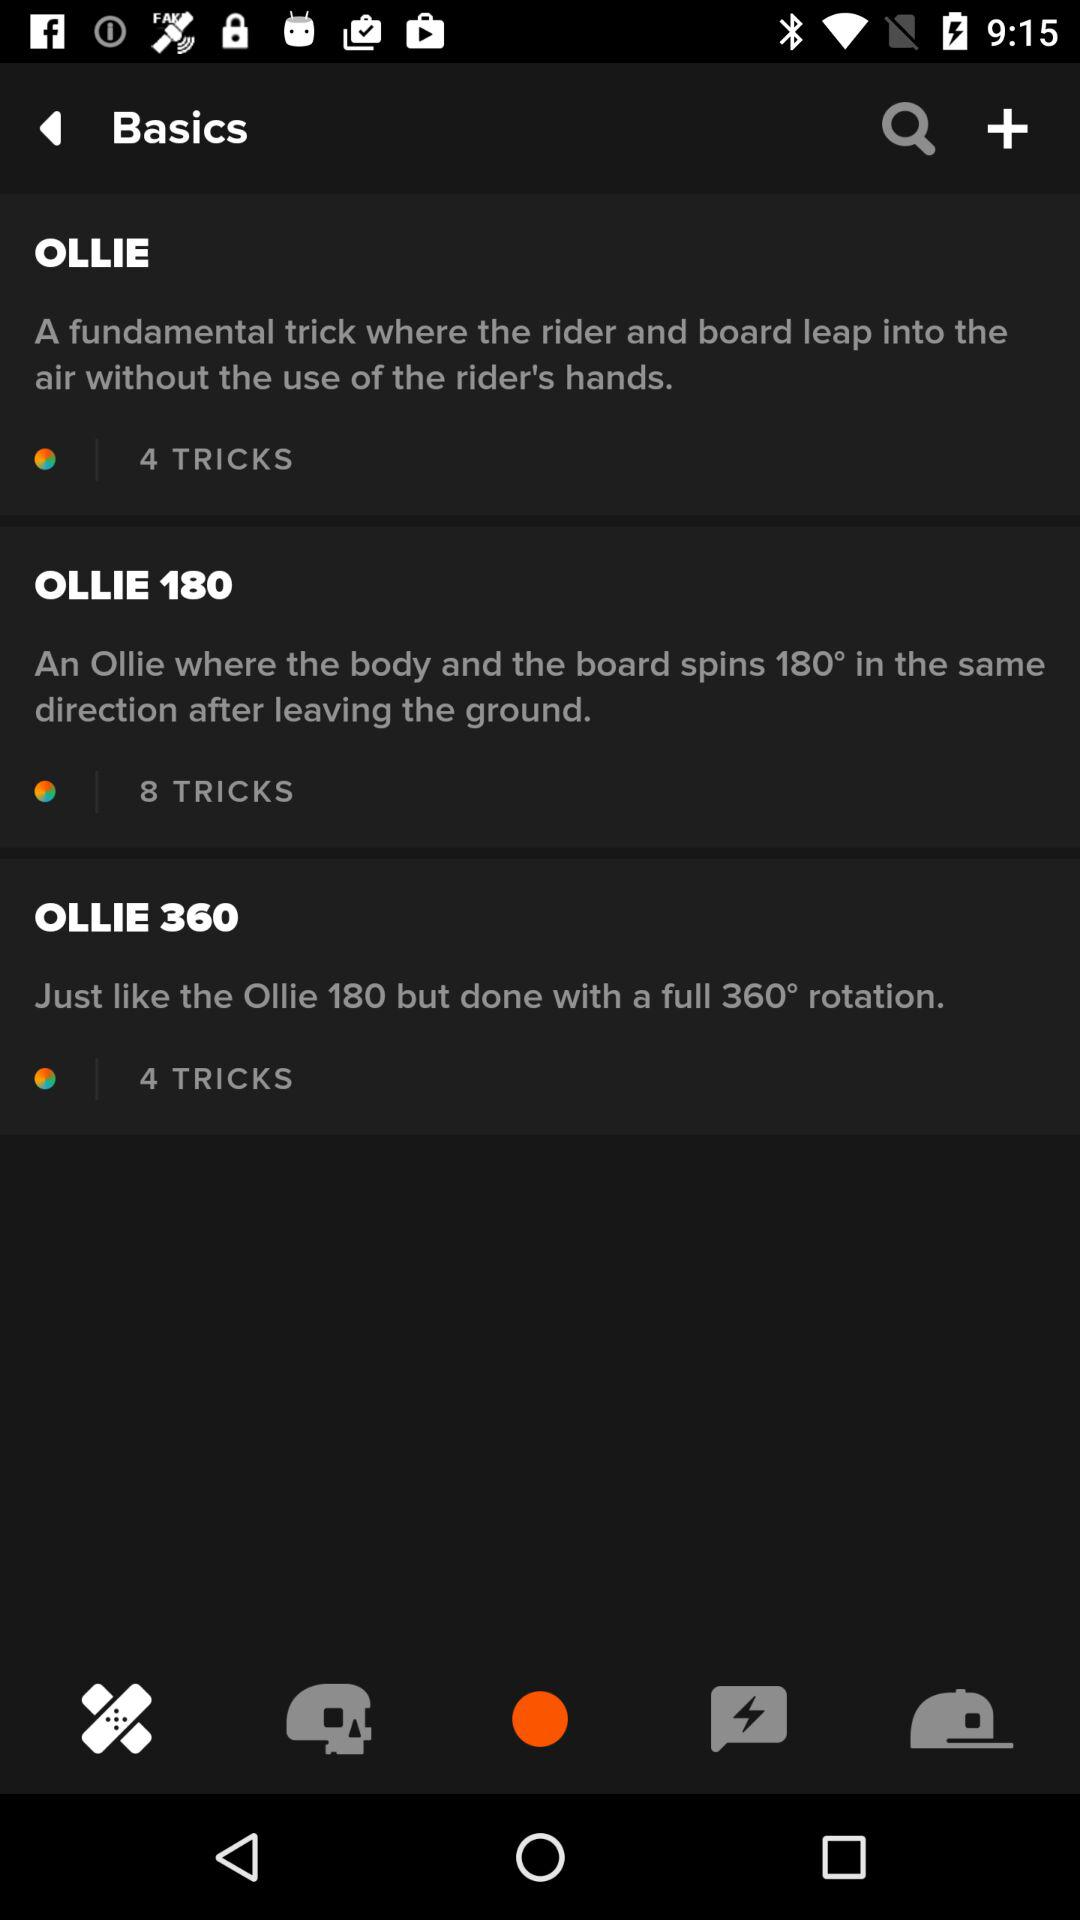How many tricks are there in "OLLIE"? There are 4 tricks. 